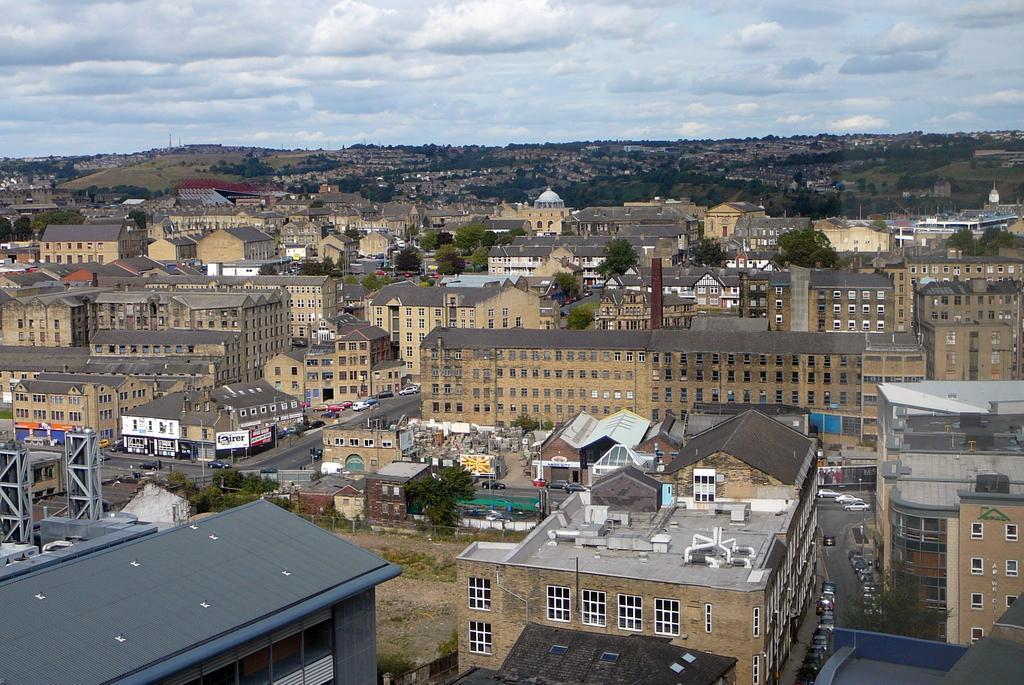Could you give a brief overview of what you see in this image? In this image, we can see so many buildings, walls, windows, roads, vehicles, trees, poles, roofs, banners and few objects. Top of the image, there is a cloudy sky. 